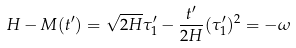<formula> <loc_0><loc_0><loc_500><loc_500>H - M ( t ^ { \prime } ) = \sqrt { 2 H } \tau _ { 1 } ^ { \prime } - \frac { t ^ { \prime } } { 2 H } ( \tau _ { 1 } ^ { \prime } ) ^ { 2 } = - \omega</formula> 